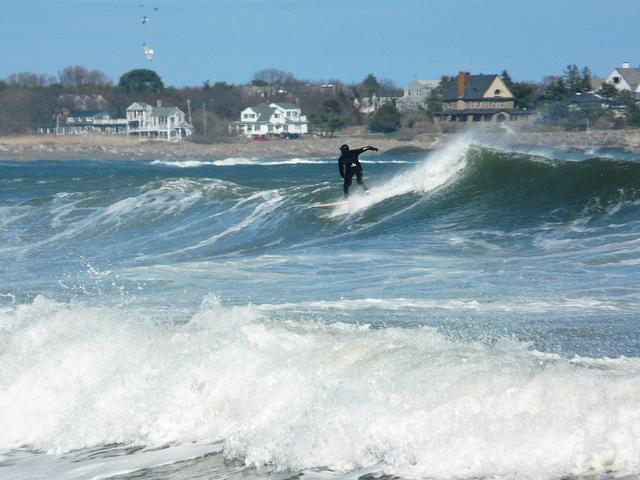How is this setting an unusual place to find surfers?
Answer briefly. No. Is there a SCUBA diver?
Concise answer only. No. Is it a cloudy day?
Quick response, please. No. What color is the wetsuit?
Write a very short answer. Black. What is the brown lump on the left of the picture?
Be succinct. Sand. Are there a lot of waves?
Be succinct. Yes. What building is in the background?
Quick response, please. House. Is anyone swimming?
Give a very brief answer. No. 